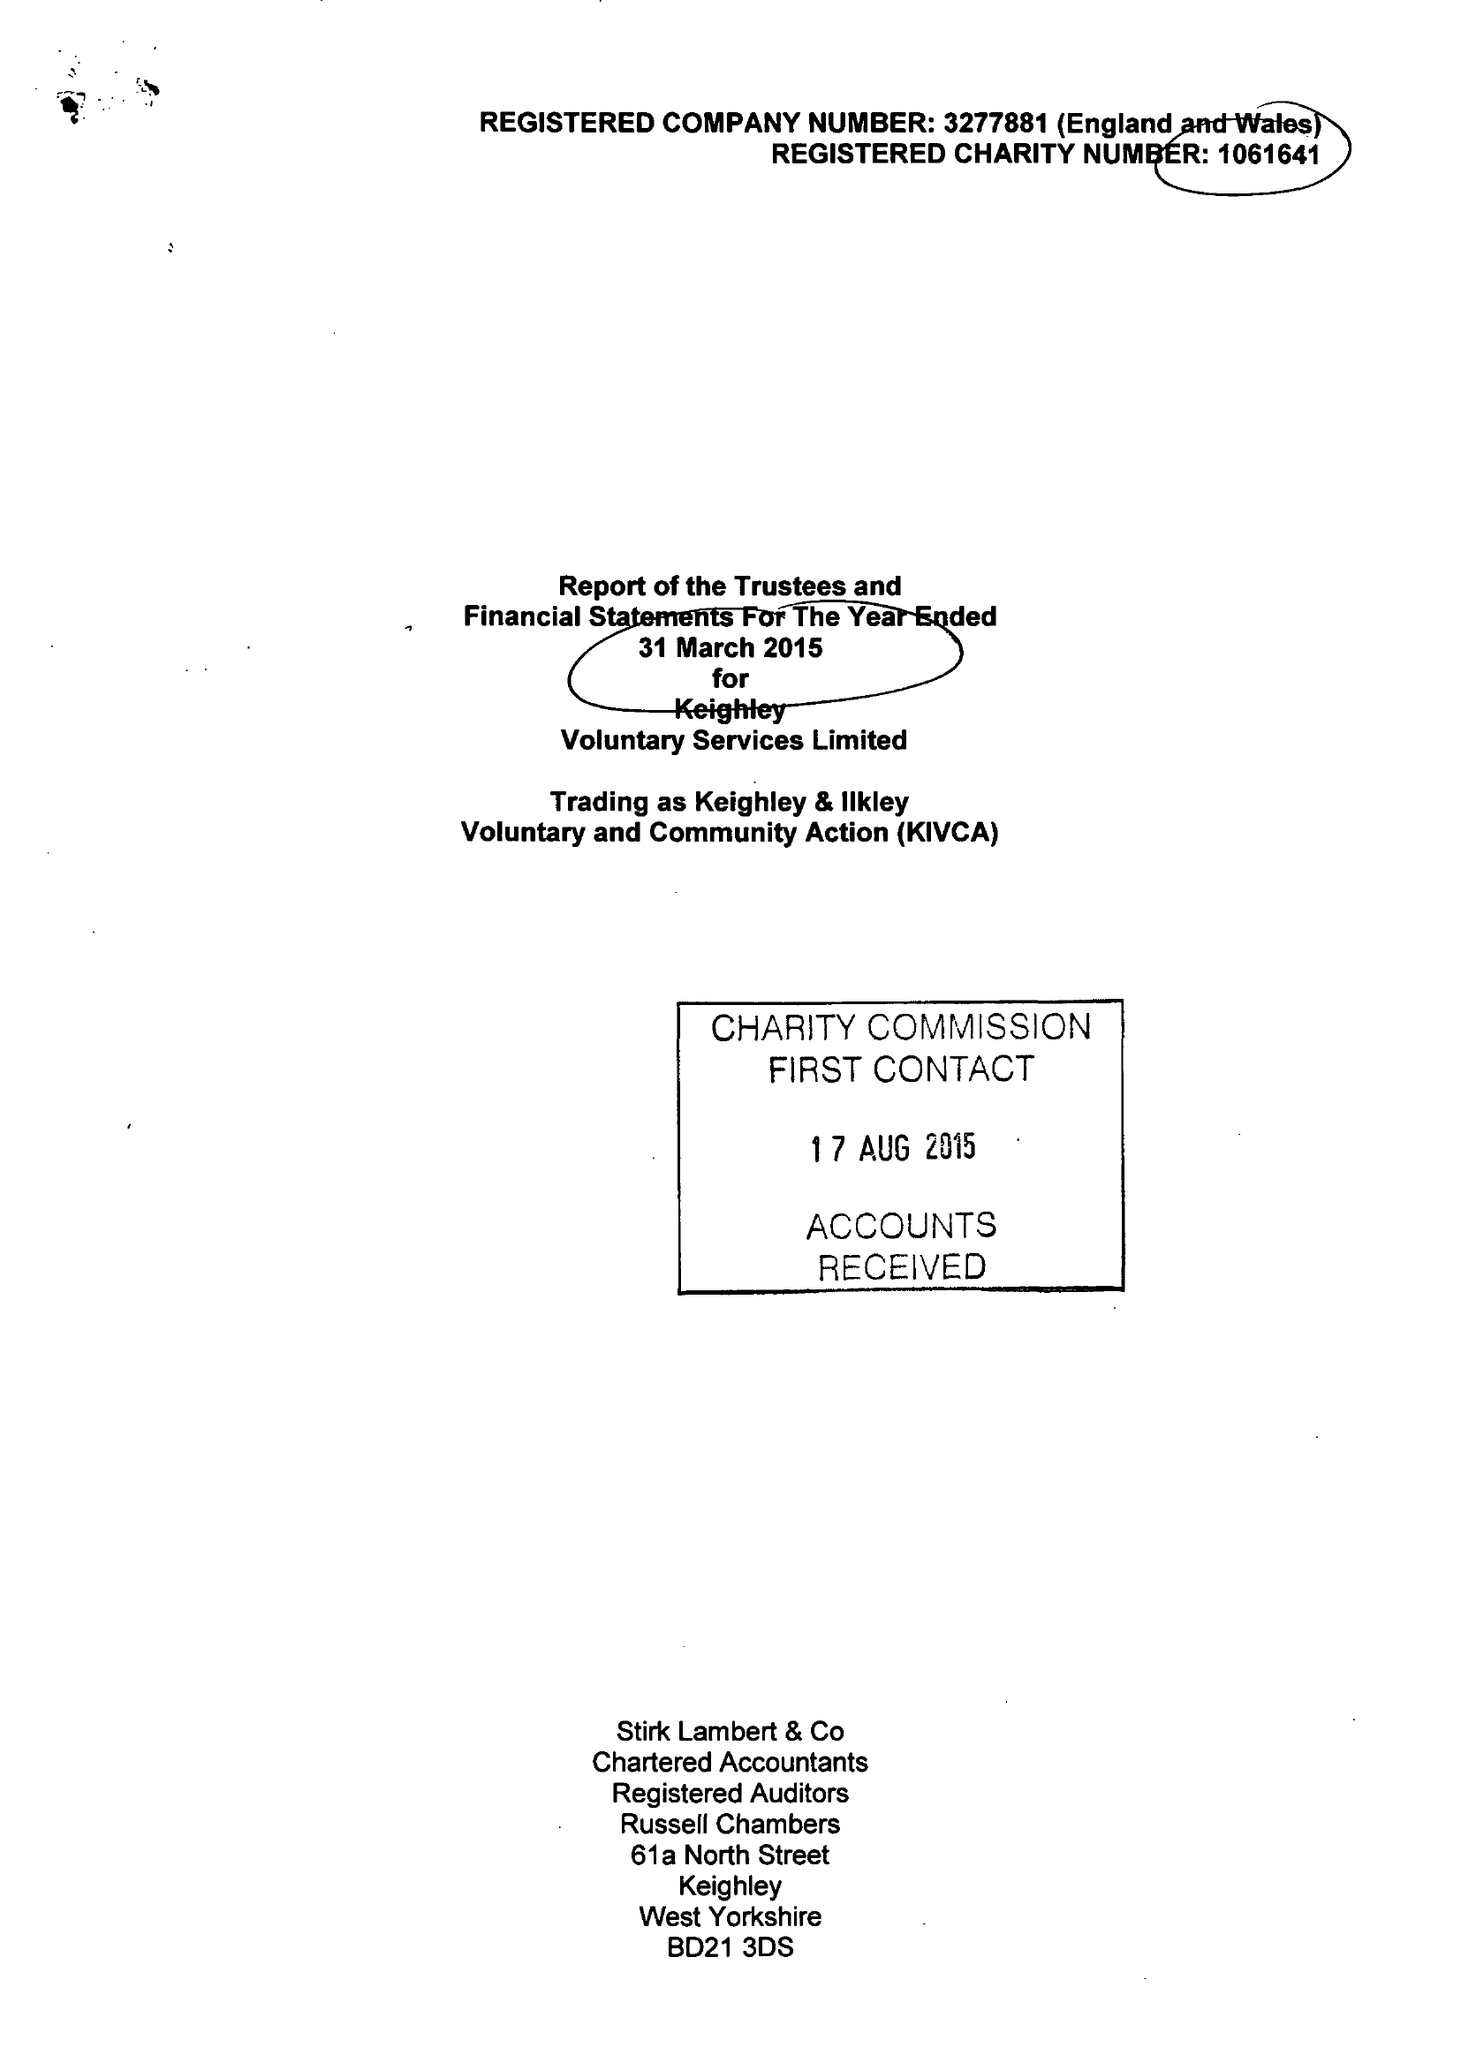What is the value for the report_date?
Answer the question using a single word or phrase. 2015-03-31 